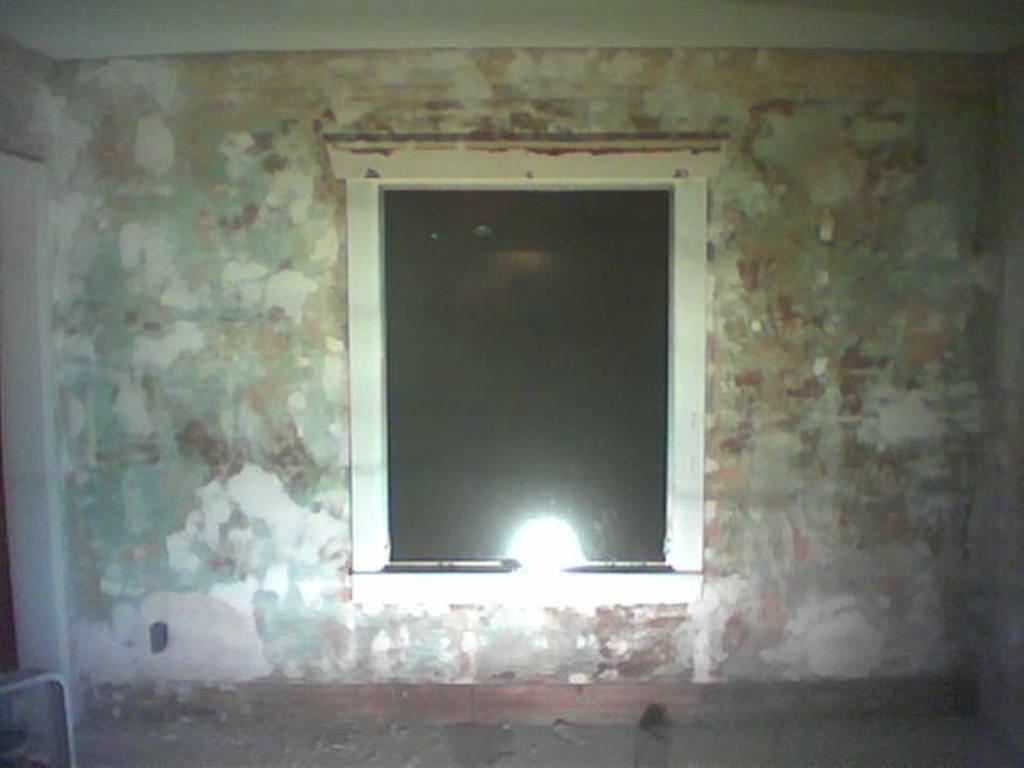Where was the image taken? The image was taken in a room. What can be seen in the center of the image? There is a window in the center of the image. What is one of the main architectural features in the image? There is a wall in the image. What is the reaction of the crib to the picture in the image? There is no crib or picture present in the image, so it is not possible to determine any reaction. 